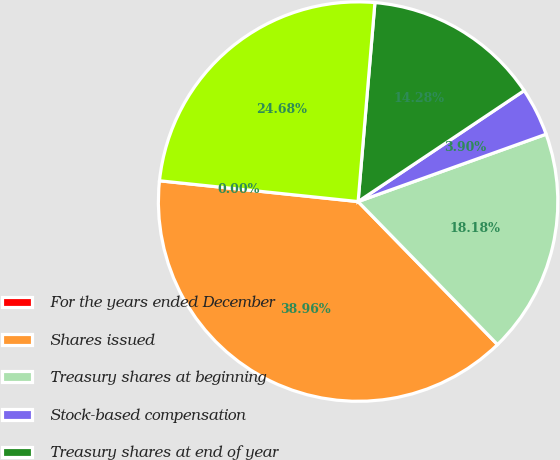<chart> <loc_0><loc_0><loc_500><loc_500><pie_chart><fcel>For the years ended December<fcel>Shares issued<fcel>Treasury shares at beginning<fcel>Stock-based compensation<fcel>Treasury shares at end of year<fcel>Net shares outstanding at end<nl><fcel>0.0%<fcel>38.96%<fcel>18.18%<fcel>3.9%<fcel>14.28%<fcel>24.68%<nl></chart> 